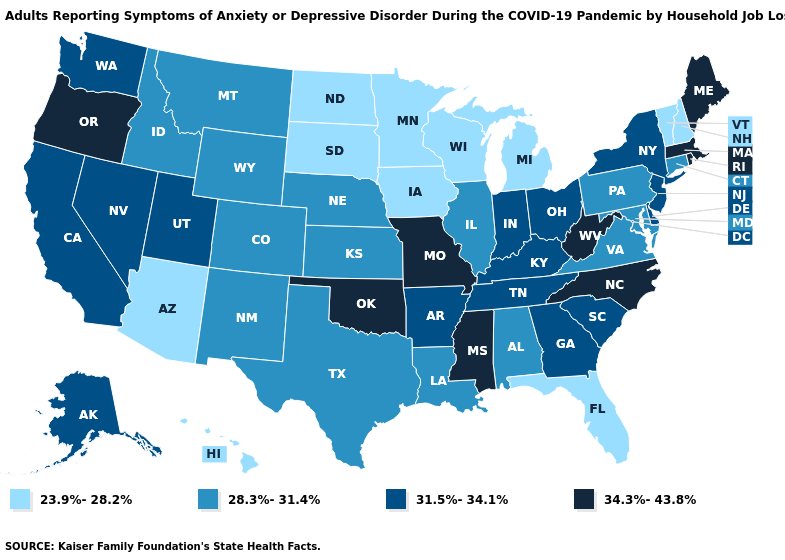What is the value of Florida?
Short answer required. 23.9%-28.2%. Which states hav the highest value in the Northeast?
Write a very short answer. Maine, Massachusetts, Rhode Island. Name the states that have a value in the range 34.3%-43.8%?
Write a very short answer. Maine, Massachusetts, Mississippi, Missouri, North Carolina, Oklahoma, Oregon, Rhode Island, West Virginia. Does Minnesota have a lower value than Vermont?
Be succinct. No. Name the states that have a value in the range 23.9%-28.2%?
Concise answer only. Arizona, Florida, Hawaii, Iowa, Michigan, Minnesota, New Hampshire, North Dakota, South Dakota, Vermont, Wisconsin. What is the lowest value in states that border Georgia?
Be succinct. 23.9%-28.2%. Does New Jersey have the same value as Tennessee?
Keep it brief. Yes. Which states have the lowest value in the USA?
Be succinct. Arizona, Florida, Hawaii, Iowa, Michigan, Minnesota, New Hampshire, North Dakota, South Dakota, Vermont, Wisconsin. Among the states that border Florida , which have the highest value?
Answer briefly. Georgia. Among the states that border Illinois , does Missouri have the highest value?
Short answer required. Yes. Name the states that have a value in the range 23.9%-28.2%?
Keep it brief. Arizona, Florida, Hawaii, Iowa, Michigan, Minnesota, New Hampshire, North Dakota, South Dakota, Vermont, Wisconsin. Name the states that have a value in the range 23.9%-28.2%?
Concise answer only. Arizona, Florida, Hawaii, Iowa, Michigan, Minnesota, New Hampshire, North Dakota, South Dakota, Vermont, Wisconsin. What is the lowest value in the West?
Answer briefly. 23.9%-28.2%. Which states have the highest value in the USA?
Answer briefly. Maine, Massachusetts, Mississippi, Missouri, North Carolina, Oklahoma, Oregon, Rhode Island, West Virginia. Which states have the lowest value in the Northeast?
Answer briefly. New Hampshire, Vermont. 